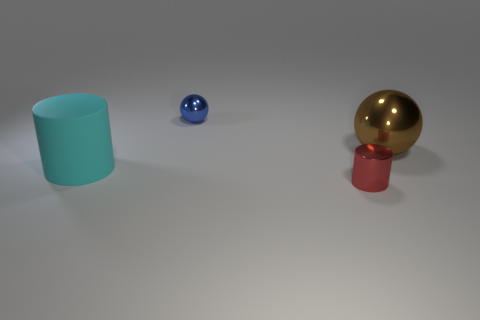What are the textures of the objects seen in the image? The cylindrical object has a matte finish, the small blue sphere has a smooth, slightly reflective surface, and the gold ball has a highly reflective, shiny texture that mirrors its surroundings. 